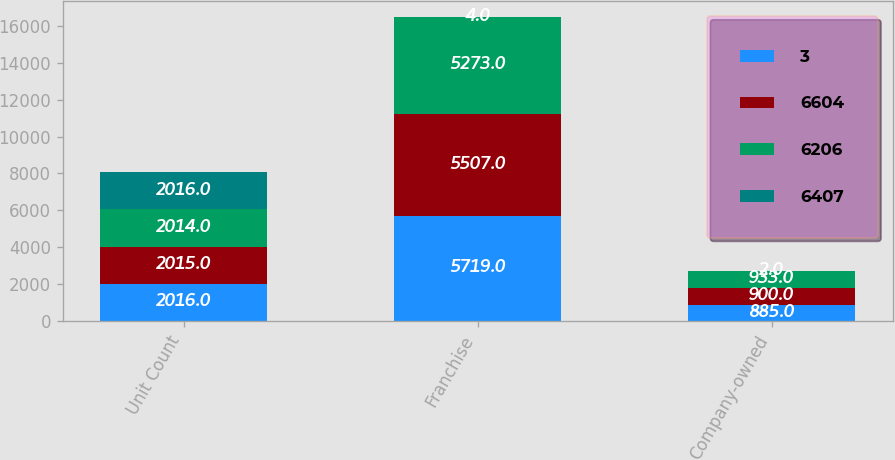Convert chart to OTSL. <chart><loc_0><loc_0><loc_500><loc_500><stacked_bar_chart><ecel><fcel>Unit Count<fcel>Franchise<fcel>Company-owned<nl><fcel>3<fcel>2016<fcel>5719<fcel>885<nl><fcel>6604<fcel>2015<fcel>5507<fcel>900<nl><fcel>6206<fcel>2014<fcel>5273<fcel>933<nl><fcel>6407<fcel>2016<fcel>4<fcel>2<nl></chart> 